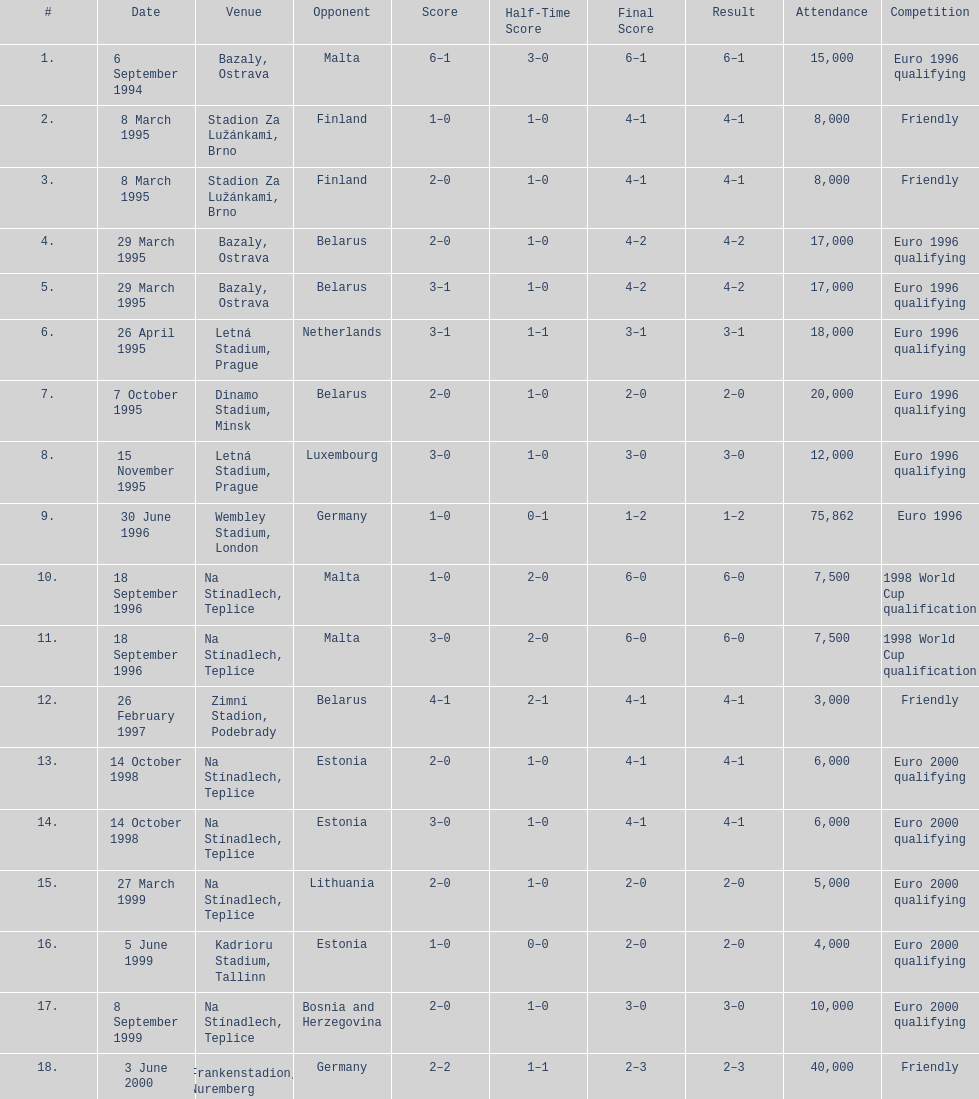How many total games took place in 1999? 3. 